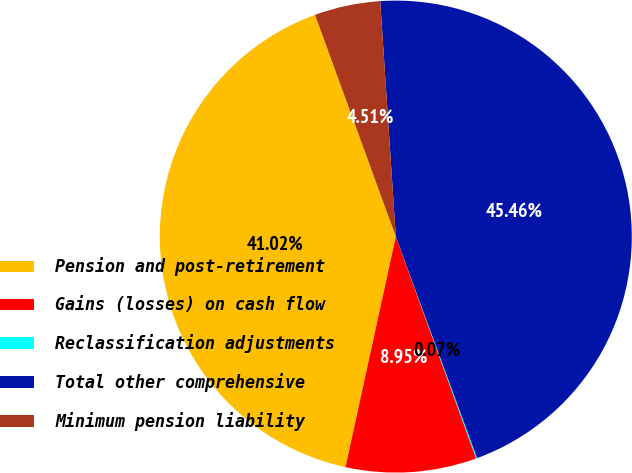<chart> <loc_0><loc_0><loc_500><loc_500><pie_chart><fcel>Pension and post-retirement<fcel>Gains (losses) on cash flow<fcel>Reclassification adjustments<fcel>Total other comprehensive<fcel>Minimum pension liability<nl><fcel>41.02%<fcel>8.95%<fcel>0.07%<fcel>45.46%<fcel>4.51%<nl></chart> 